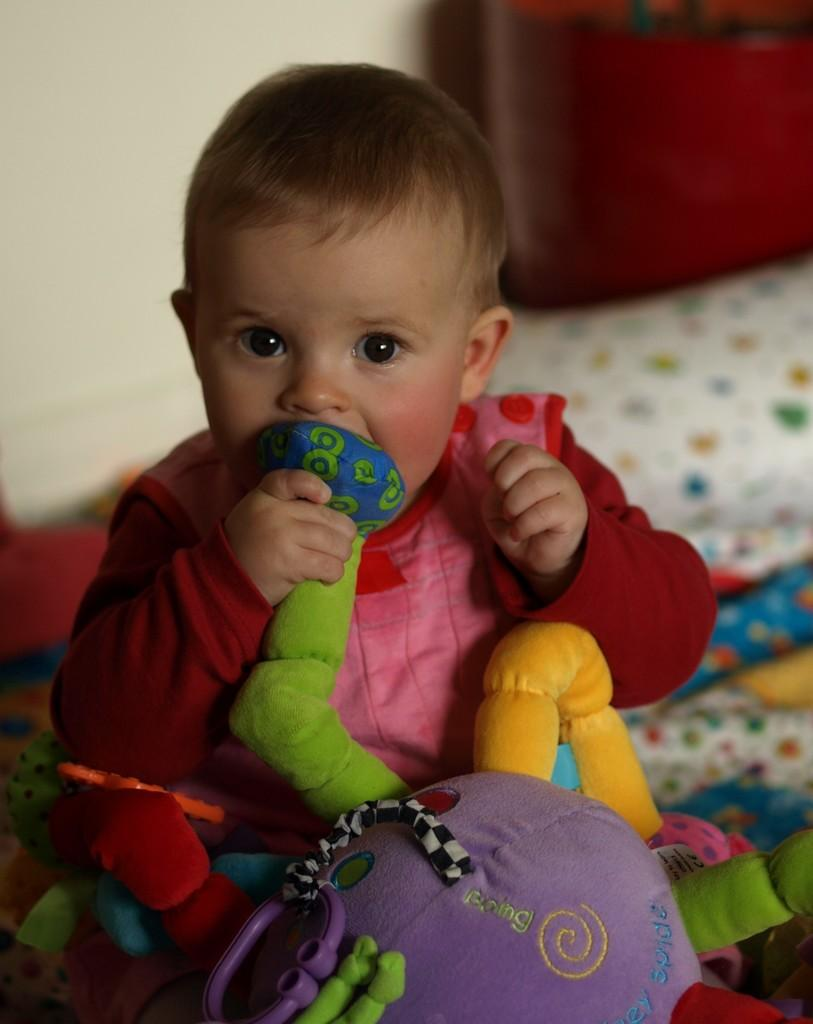What is the main subject of the image? The main subject of the image is a baby. What is the baby holding in the image? The baby is holding a soft toy. Can you describe the background of the image? The background of the image is blurred. What type of roof can be seen in the image? There is no roof present in the image. What is the baby learning in the image? The image does not depict the baby learning anything specific. 